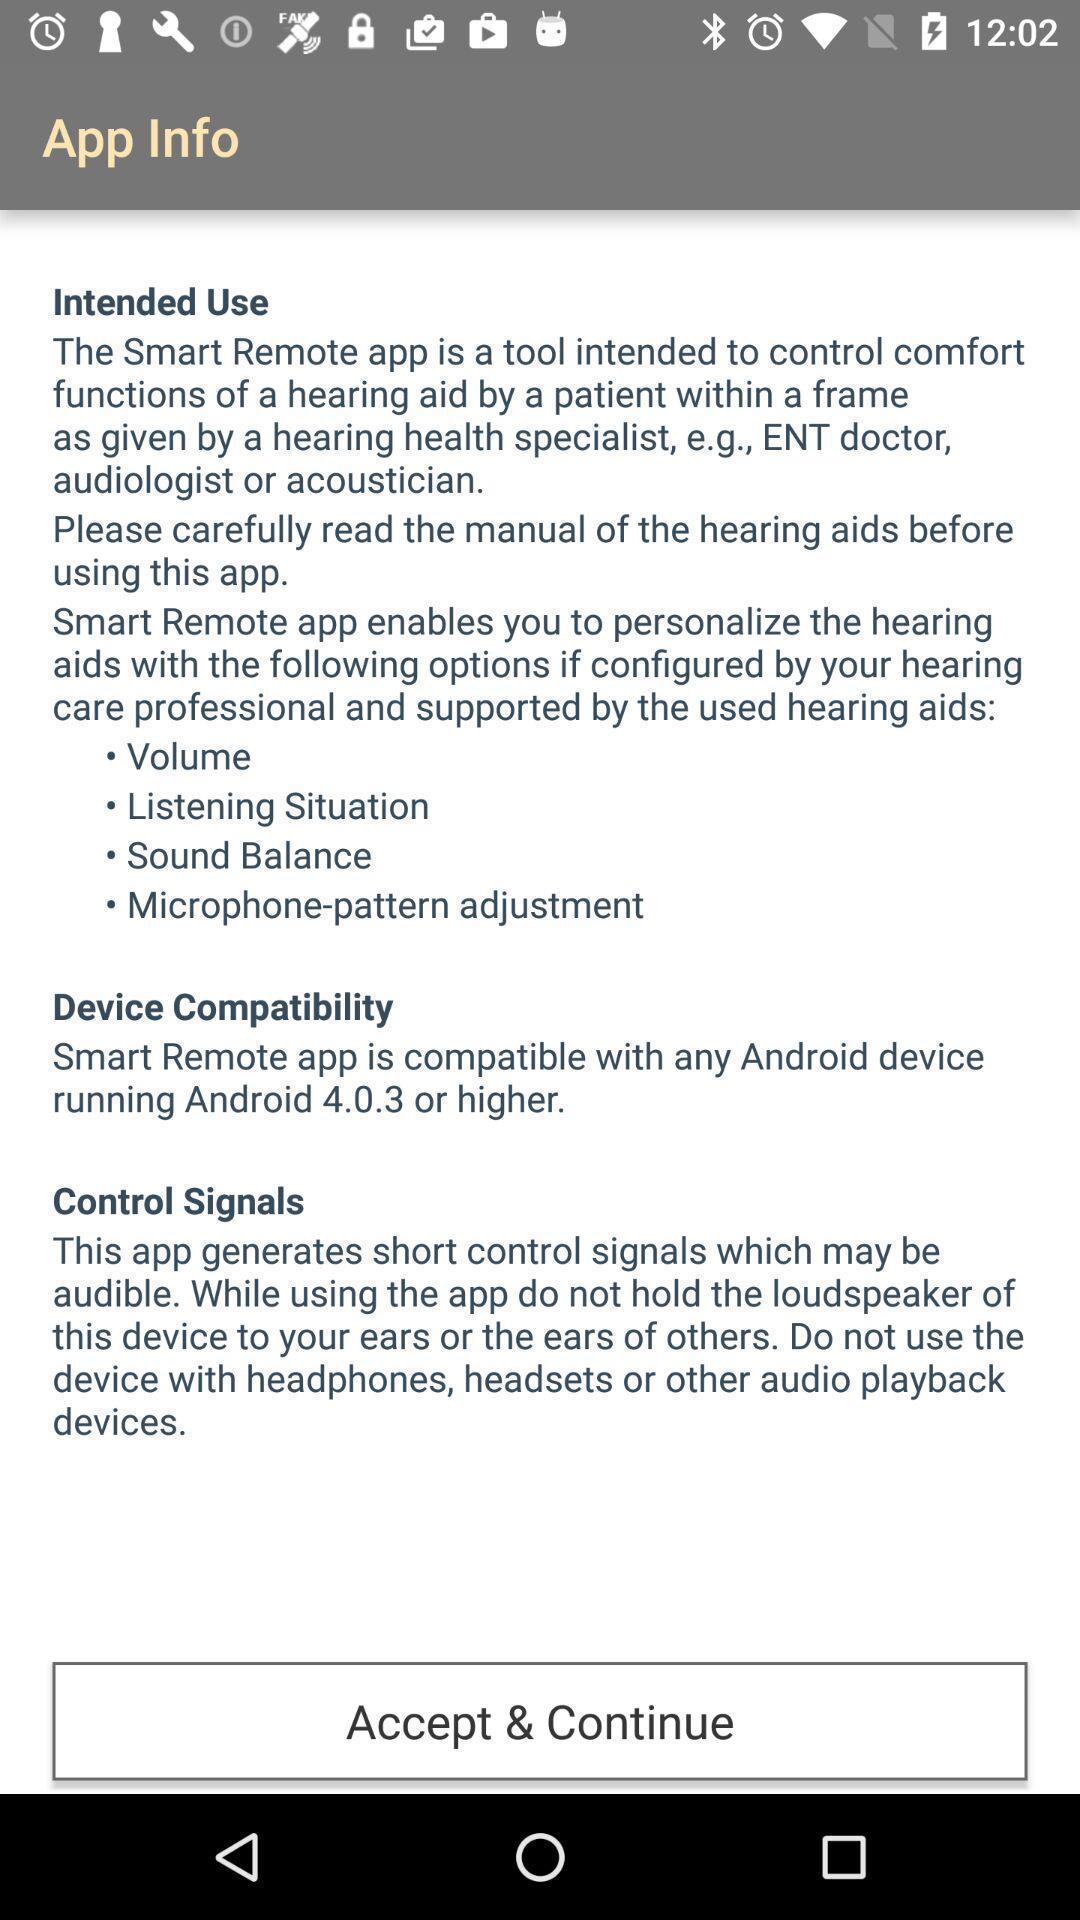What details can you identify in this image? Page with app info of remote control app. 